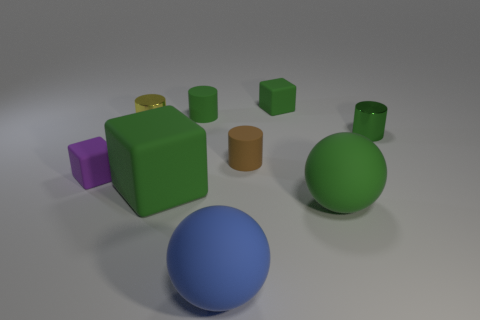What is the material of the tiny cube that is the same color as the large rubber cube?
Make the answer very short. Rubber. What is the size of the green cube that is on the left side of the sphere in front of the green rubber sphere?
Offer a terse response. Large. Are there any tiny yellow spheres made of the same material as the yellow cylinder?
Your response must be concise. No. What material is the other ball that is the same size as the blue ball?
Your response must be concise. Rubber. There is a small metallic object that is to the right of the small brown thing; is it the same color as the rubber thing that is to the left of the small yellow cylinder?
Give a very brief answer. No. There is a cube to the left of the big cube; are there any cubes behind it?
Your answer should be compact. Yes. Is the shape of the shiny thing on the left side of the green metal cylinder the same as the big object behind the green matte sphere?
Your answer should be compact. No. Are the tiny green object on the left side of the large blue matte object and the tiny object that is on the right side of the tiny green block made of the same material?
Offer a terse response. No. There is a small block that is on the right side of the matte thing on the left side of the large matte cube; what is its material?
Your answer should be very brief. Rubber. There is a large green object that is left of the green rubber cylinder that is behind the blue matte ball that is to the right of the small yellow thing; what is its shape?
Ensure brevity in your answer.  Cube. 